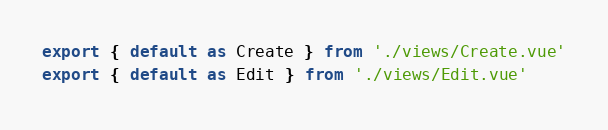Convert code to text. <code><loc_0><loc_0><loc_500><loc_500><_JavaScript_>export { default as Create } from './views/Create.vue'
export { default as Edit } from './views/Edit.vue'
</code> 